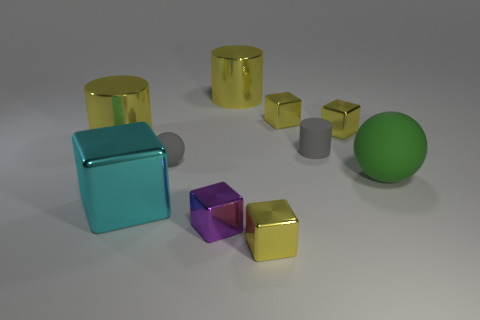Are there any gray things that have the same shape as the large green matte thing?
Provide a succinct answer. Yes. There is a yellow cube that is to the right of the gray rubber cylinder; is it the same size as the metallic cylinder that is on the right side of the cyan shiny cube?
Ensure brevity in your answer.  No. Are there more green things than yellow metallic cylinders?
Provide a short and direct response. No. What number of tiny cyan cylinders have the same material as the small purple cube?
Your response must be concise. 0. Do the big rubber object and the purple thing have the same shape?
Keep it short and to the point. No. There is a shiny cylinder that is on the left side of the big thing that is in front of the green matte ball to the right of the gray cylinder; how big is it?
Your answer should be compact. Large. Is there a yellow shiny object left of the small yellow metallic block that is in front of the big green sphere?
Offer a terse response. Yes. There is a small object that is right of the rubber thing that is behind the gray matte ball; what number of tiny gray matte balls are to the right of it?
Keep it short and to the point. 0. The big metal object that is both behind the big cyan shiny thing and on the left side of the purple thing is what color?
Provide a short and direct response. Yellow. What number of shiny cubes have the same color as the small rubber cylinder?
Your answer should be very brief. 0. 